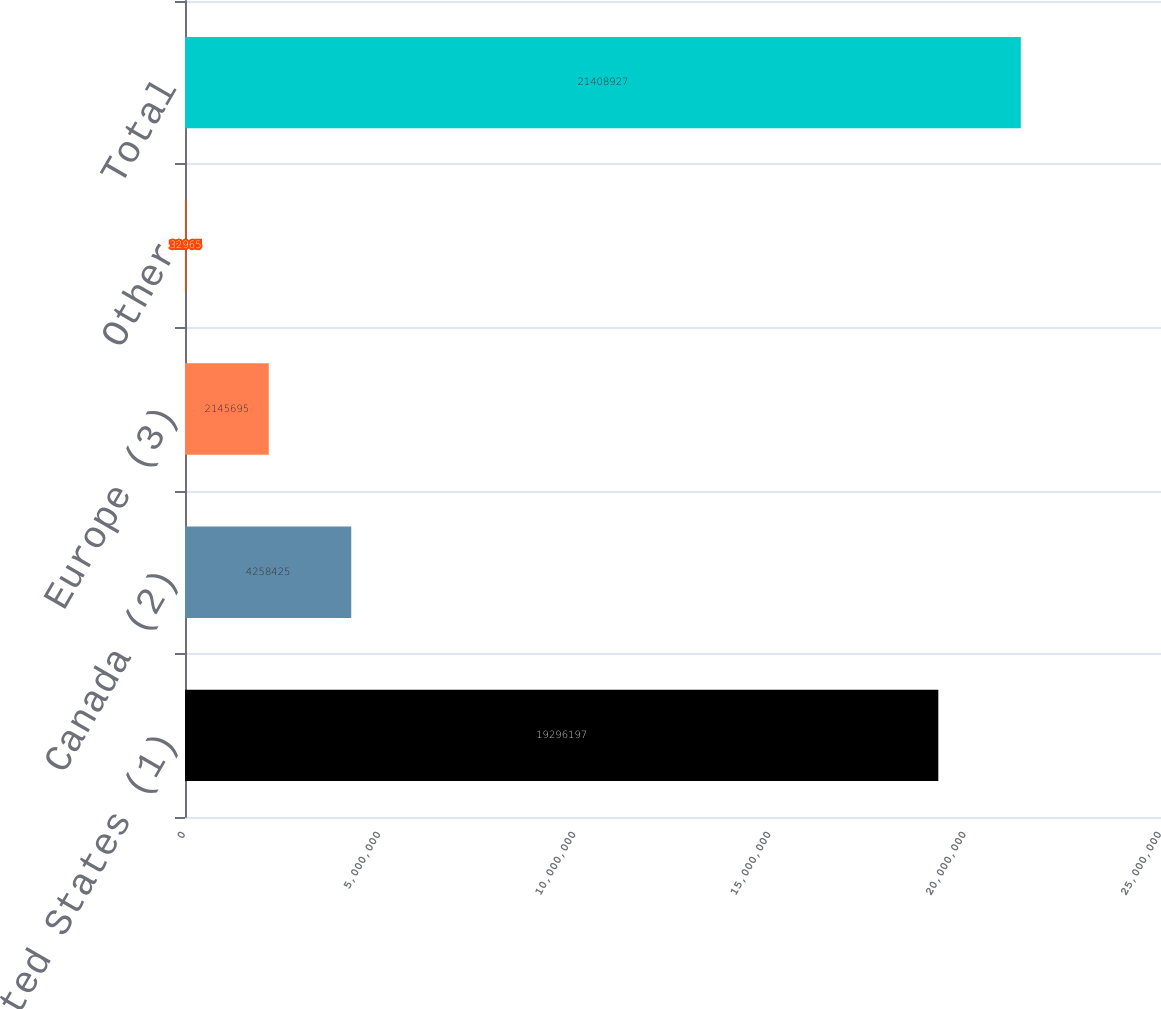Convert chart to OTSL. <chart><loc_0><loc_0><loc_500><loc_500><bar_chart><fcel>United States (1)<fcel>Canada (2)<fcel>Europe (3)<fcel>Other<fcel>Total<nl><fcel>1.92962e+07<fcel>4.25842e+06<fcel>2.1457e+06<fcel>32965<fcel>2.14089e+07<nl></chart> 